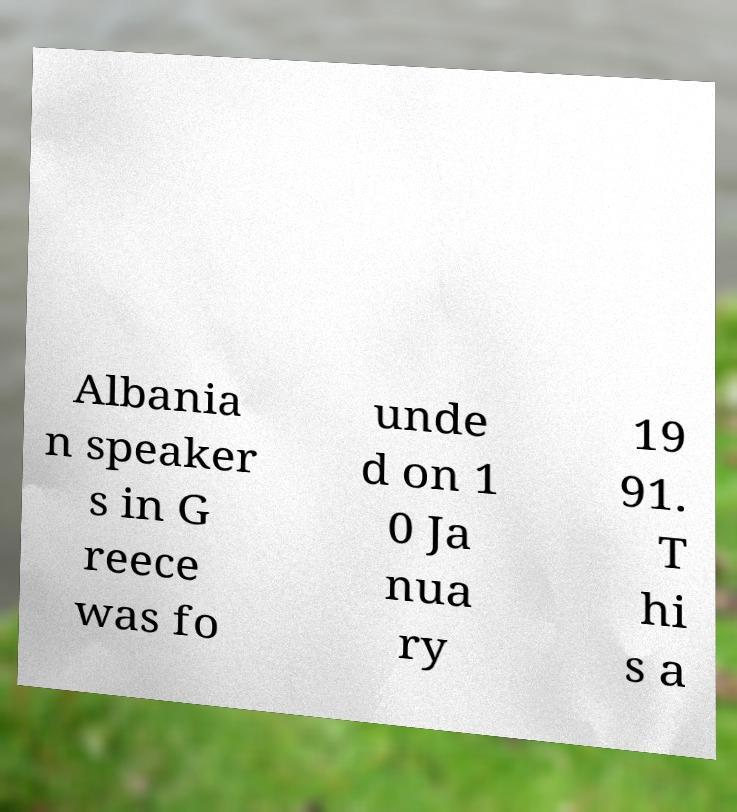Can you accurately transcribe the text from the provided image for me? Albania n speaker s in G reece was fo unde d on 1 0 Ja nua ry 19 91. T hi s a 